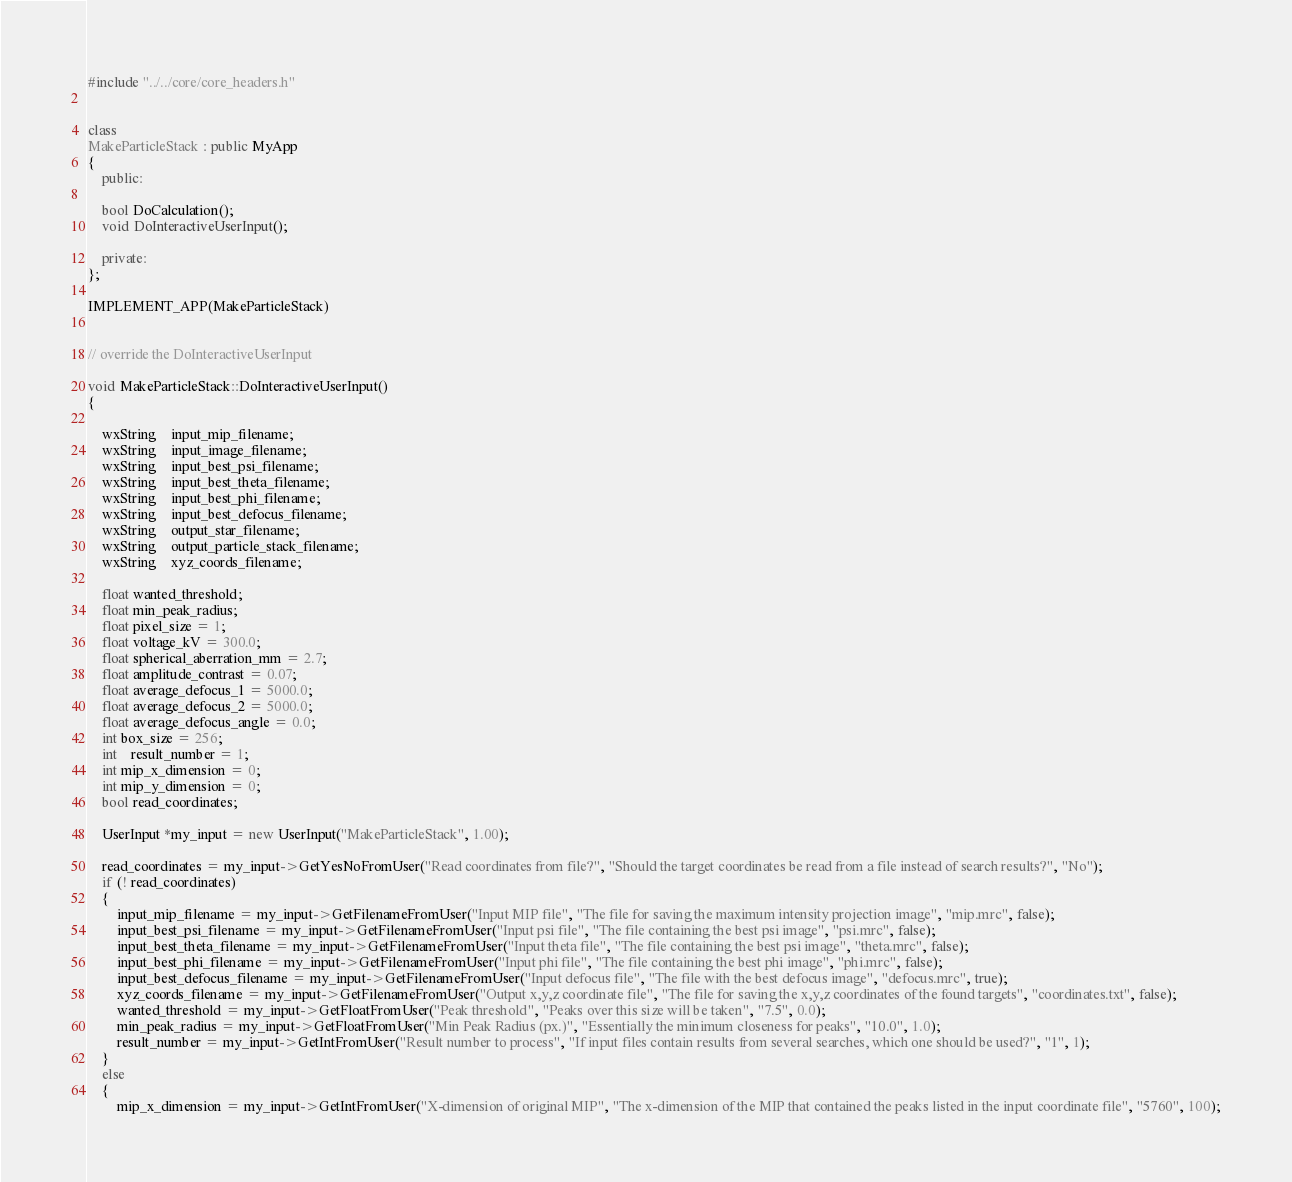Convert code to text. <code><loc_0><loc_0><loc_500><loc_500><_C++_>#include "../../core/core_headers.h"


class
MakeParticleStack : public MyApp
{
	public:

	bool DoCalculation();
	void DoInteractiveUserInput();

	private:
};

IMPLEMENT_APP(MakeParticleStack)


// override the DoInteractiveUserInput

void MakeParticleStack::DoInteractiveUserInput()
{

	wxString    input_mip_filename;
	wxString    input_image_filename;
	wxString    input_best_psi_filename;
	wxString    input_best_theta_filename;
	wxString    input_best_phi_filename;
	wxString    input_best_defocus_filename;
	wxString    output_star_filename;
	wxString    output_particle_stack_filename;
	wxString    xyz_coords_filename;

	float wanted_threshold;
	float min_peak_radius;
	float pixel_size = 1;
	float voltage_kV = 300.0;
	float spherical_aberration_mm = 2.7;
	float amplitude_contrast = 0.07;
	float average_defocus_1 = 5000.0;
	float average_defocus_2 = 5000.0;
	float average_defocus_angle = 0.0;
	int box_size = 256;
	int	result_number = 1;
	int mip_x_dimension = 0;
	int mip_y_dimension = 0;
	bool read_coordinates;

	UserInput *my_input = new UserInput("MakeParticleStack", 1.00);

	read_coordinates = my_input->GetYesNoFromUser("Read coordinates from file?", "Should the target coordinates be read from a file instead of search results?", "No");
	if (! read_coordinates)
	{
		input_mip_filename = my_input->GetFilenameFromUser("Input MIP file", "The file for saving the maximum intensity projection image", "mip.mrc", false);
		input_best_psi_filename = my_input->GetFilenameFromUser("Input psi file", "The file containing the best psi image", "psi.mrc", false);
		input_best_theta_filename = my_input->GetFilenameFromUser("Input theta file", "The file containing the best psi image", "theta.mrc", false);
		input_best_phi_filename = my_input->GetFilenameFromUser("Input phi file", "The file containing the best phi image", "phi.mrc", false);
		input_best_defocus_filename = my_input->GetFilenameFromUser("Input defocus file", "The file with the best defocus image", "defocus.mrc", true);
		xyz_coords_filename = my_input->GetFilenameFromUser("Output x,y,z coordinate file", "The file for saving the x,y,z coordinates of the found targets", "coordinates.txt", false);
		wanted_threshold = my_input->GetFloatFromUser("Peak threshold", "Peaks over this size will be taken", "7.5", 0.0);
		min_peak_radius = my_input->GetFloatFromUser("Min Peak Radius (px.)", "Essentially the minimum closeness for peaks", "10.0", 1.0);
		result_number = my_input->GetIntFromUser("Result number to process", "If input files contain results from several searches, which one should be used?", "1", 1);
	}
	else
	{
		mip_x_dimension = my_input->GetIntFromUser("X-dimension of original MIP", "The x-dimension of the MIP that contained the peaks listed in the input coordinate file", "5760", 100);</code> 